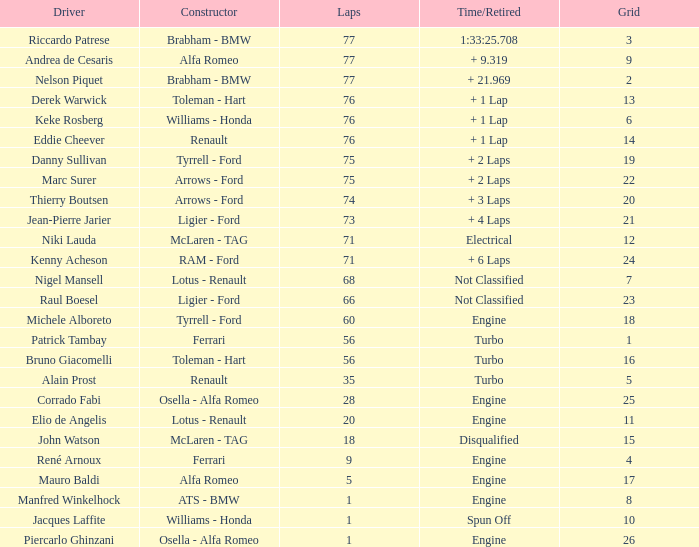Who was the driver of the car that did not complete 60 laps and experienced a spin-off? Jacques Laffite. 